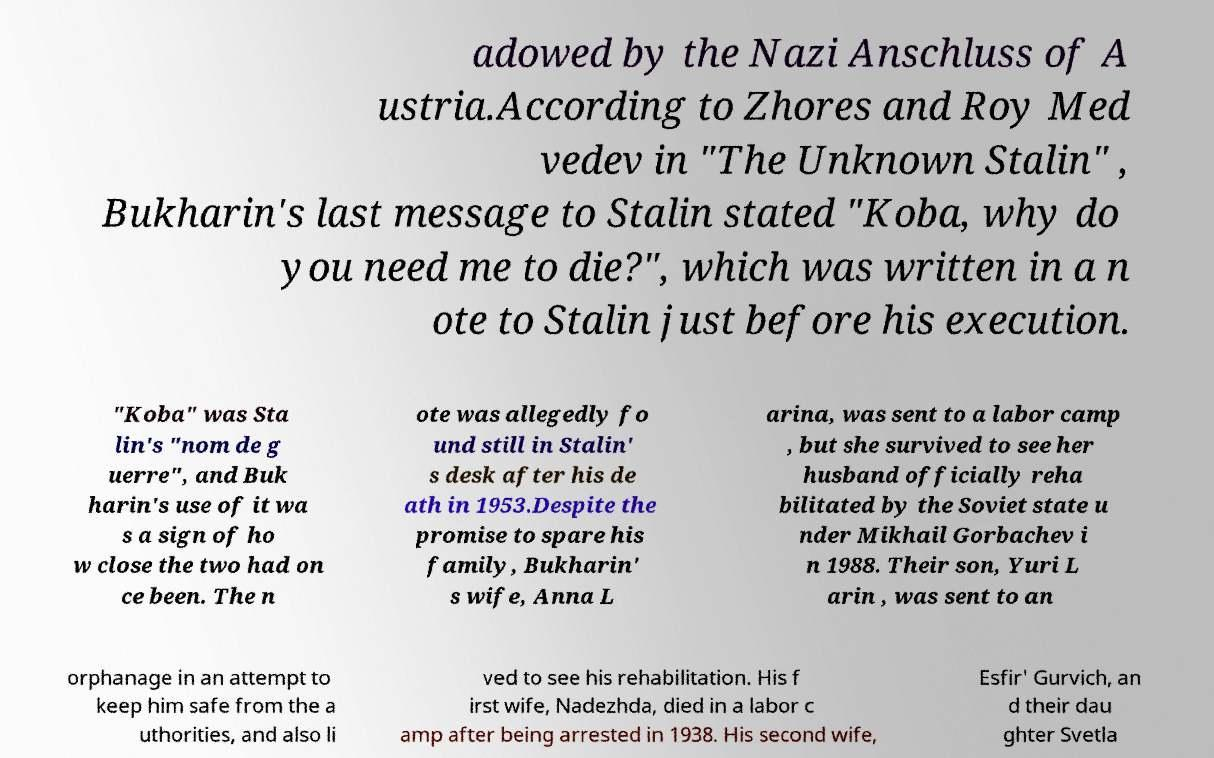Please identify and transcribe the text found in this image. adowed by the Nazi Anschluss of A ustria.According to Zhores and Roy Med vedev in "The Unknown Stalin" , Bukharin's last message to Stalin stated "Koba, why do you need me to die?", which was written in a n ote to Stalin just before his execution. "Koba" was Sta lin's "nom de g uerre", and Buk harin's use of it wa s a sign of ho w close the two had on ce been. The n ote was allegedly fo und still in Stalin' s desk after his de ath in 1953.Despite the promise to spare his family, Bukharin' s wife, Anna L arina, was sent to a labor camp , but she survived to see her husband officially reha bilitated by the Soviet state u nder Mikhail Gorbachev i n 1988. Their son, Yuri L arin , was sent to an orphanage in an attempt to keep him safe from the a uthorities, and also li ved to see his rehabilitation. His f irst wife, Nadezhda, died in a labor c amp after being arrested in 1938. His second wife, Esfir' Gurvich, an d their dau ghter Svetla 